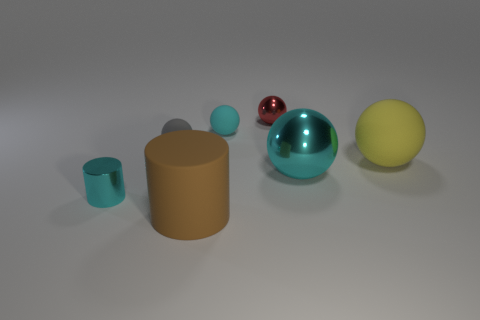Subtract all small cyan matte spheres. How many spheres are left? 4 Add 1 big red metallic cubes. How many objects exist? 8 Subtract all red spheres. How many spheres are left? 4 Subtract all gray cubes. How many cyan spheres are left? 2 Subtract 2 cylinders. How many cylinders are left? 0 Subtract all gray spheres. Subtract all blue cylinders. How many spheres are left? 4 Subtract all small cyan objects. Subtract all large brown matte objects. How many objects are left? 4 Add 4 large brown matte cylinders. How many large brown matte cylinders are left? 5 Add 7 cyan matte balls. How many cyan matte balls exist? 8 Subtract 0 blue cylinders. How many objects are left? 7 